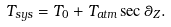<formula> <loc_0><loc_0><loc_500><loc_500>T _ { s y s } = T _ { 0 } + T _ { a t m } \sec \theta _ { Z } .</formula> 